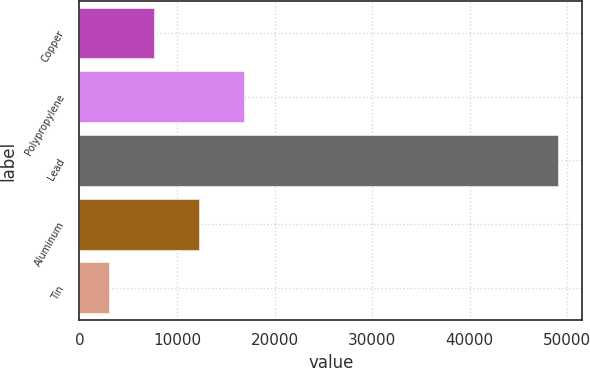Convert chart. <chart><loc_0><loc_0><loc_500><loc_500><bar_chart><fcel>Copper<fcel>Polypropylene<fcel>Lead<fcel>Aluminum<fcel>Tin<nl><fcel>7675<fcel>16873<fcel>49066<fcel>12274<fcel>3076<nl></chart> 